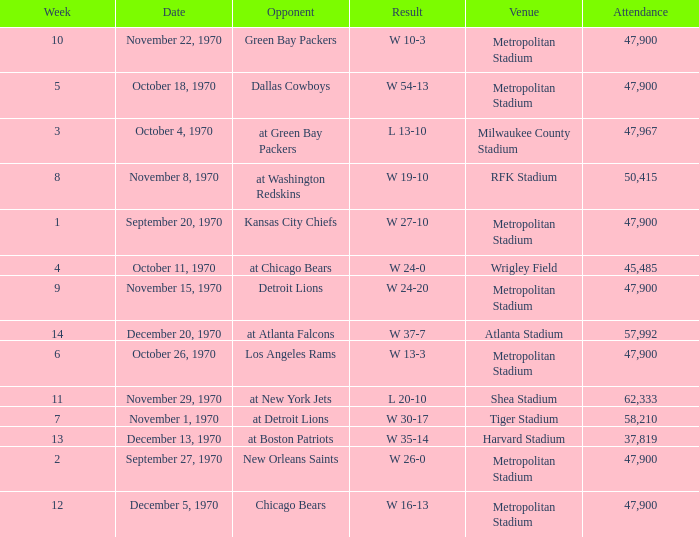How many people attended the game with a result of w 16-13 and a week earlier than 12? None. 